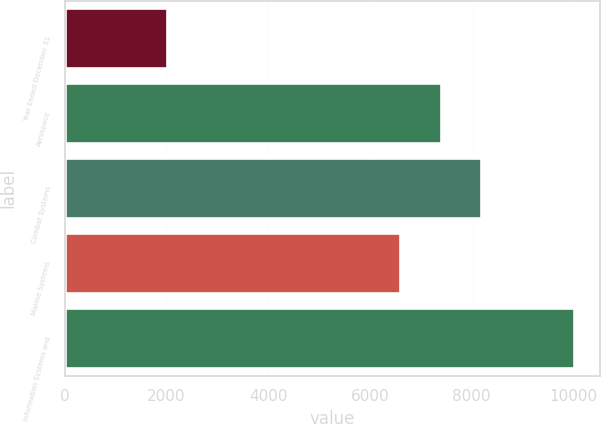Convert chart to OTSL. <chart><loc_0><loc_0><loc_500><loc_500><bar_chart><fcel>Year Ended December 31<fcel>Aerospace<fcel>Combat Systems<fcel>Marine Systems<fcel>Information Systems and<nl><fcel>2012<fcel>7392.5<fcel>8193<fcel>6592<fcel>10017<nl></chart> 